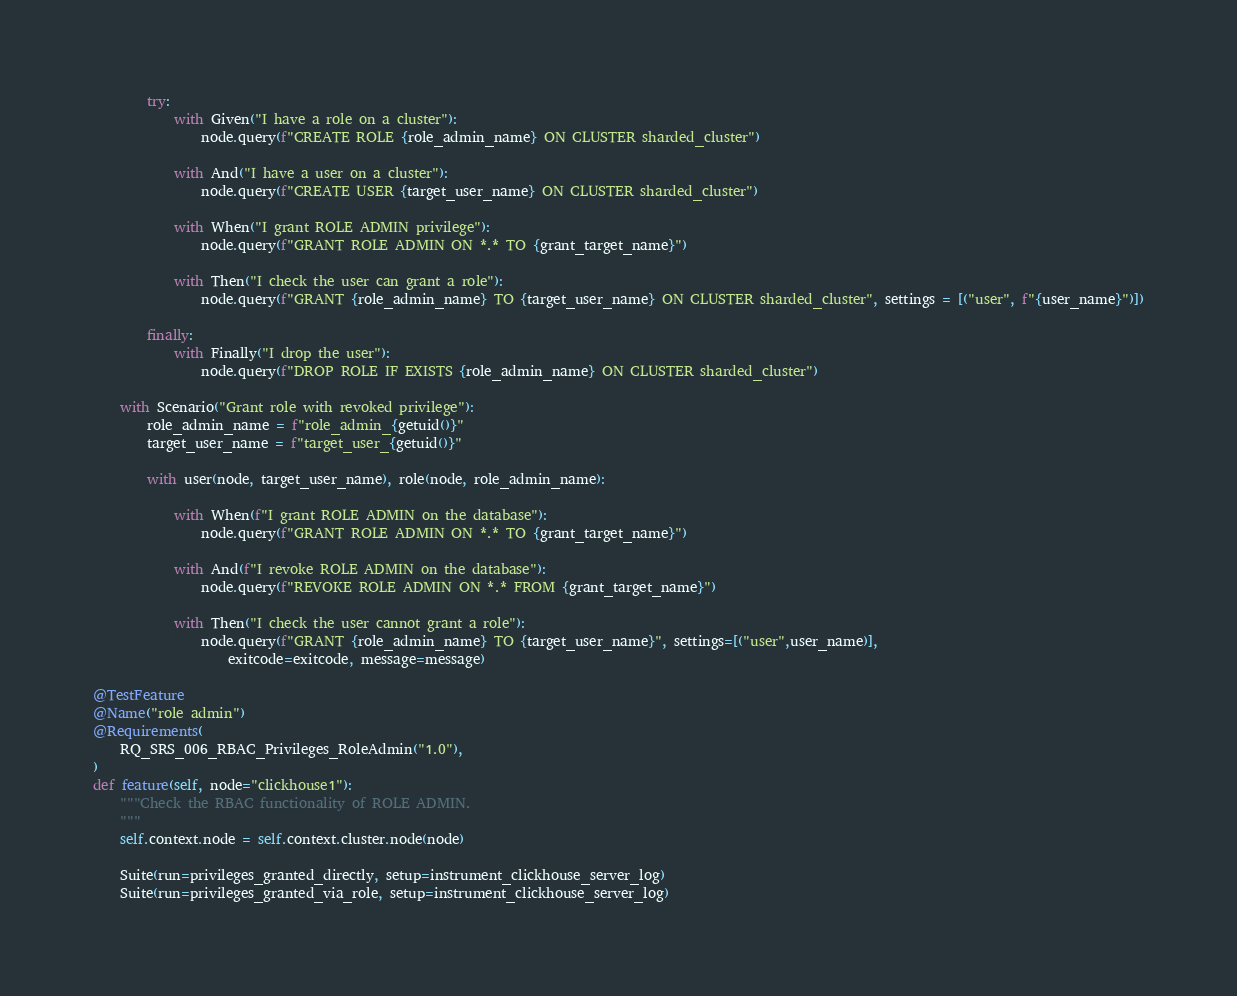Convert code to text. <code><loc_0><loc_0><loc_500><loc_500><_Python_>
        try:
            with Given("I have a role on a cluster"):
                node.query(f"CREATE ROLE {role_admin_name} ON CLUSTER sharded_cluster")

            with And("I have a user on a cluster"):
                node.query(f"CREATE USER {target_user_name} ON CLUSTER sharded_cluster")

            with When("I grant ROLE ADMIN privilege"):
                node.query(f"GRANT ROLE ADMIN ON *.* TO {grant_target_name}")

            with Then("I check the user can grant a role"):
                node.query(f"GRANT {role_admin_name} TO {target_user_name} ON CLUSTER sharded_cluster", settings = [("user", f"{user_name}")])

        finally:
            with Finally("I drop the user"):
                node.query(f"DROP ROLE IF EXISTS {role_admin_name} ON CLUSTER sharded_cluster")

    with Scenario("Grant role with revoked privilege"):
        role_admin_name = f"role_admin_{getuid()}"
        target_user_name = f"target_user_{getuid()}"

        with user(node, target_user_name), role(node, role_admin_name):

            with When(f"I grant ROLE ADMIN on the database"):
                node.query(f"GRANT ROLE ADMIN ON *.* TO {grant_target_name}")

            with And(f"I revoke ROLE ADMIN on the database"):
                node.query(f"REVOKE ROLE ADMIN ON *.* FROM {grant_target_name}")

            with Then("I check the user cannot grant a role"):
                node.query(f"GRANT {role_admin_name} TO {target_user_name}", settings=[("user",user_name)],
                    exitcode=exitcode, message=message)

@TestFeature
@Name("role admin")
@Requirements(
    RQ_SRS_006_RBAC_Privileges_RoleAdmin("1.0"),
)
def feature(self, node="clickhouse1"):
    """Check the RBAC functionality of ROLE ADMIN.
    """
    self.context.node = self.context.cluster.node(node)

    Suite(run=privileges_granted_directly, setup=instrument_clickhouse_server_log)
    Suite(run=privileges_granted_via_role, setup=instrument_clickhouse_server_log)
</code> 